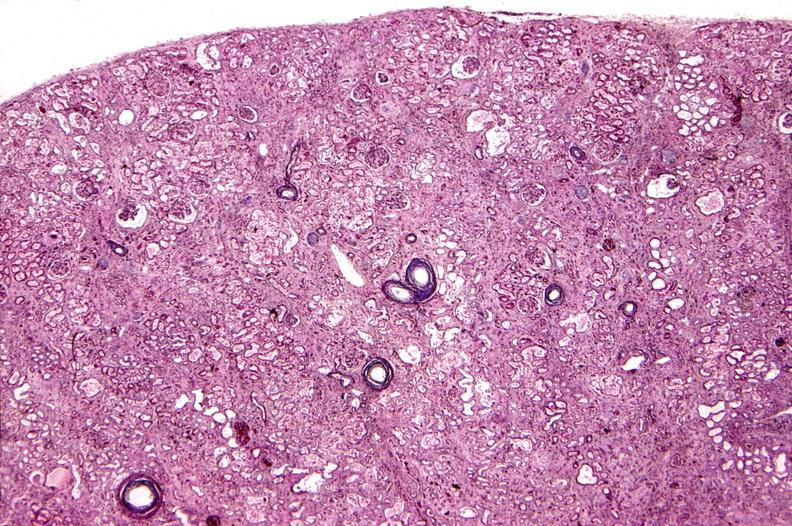where is this?
Answer the question using a single word or phrase. Urinary 